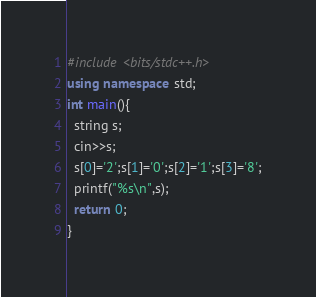Convert code to text. <code><loc_0><loc_0><loc_500><loc_500><_C++_>#include <bits/stdc++.h>
using namespace std;
int main(){
  string s;
  cin>>s;
  s[0]='2';s[1]='0';s[2]='1';s[3]='8';
  printf("%s\n",s);
  return 0;
}</code> 